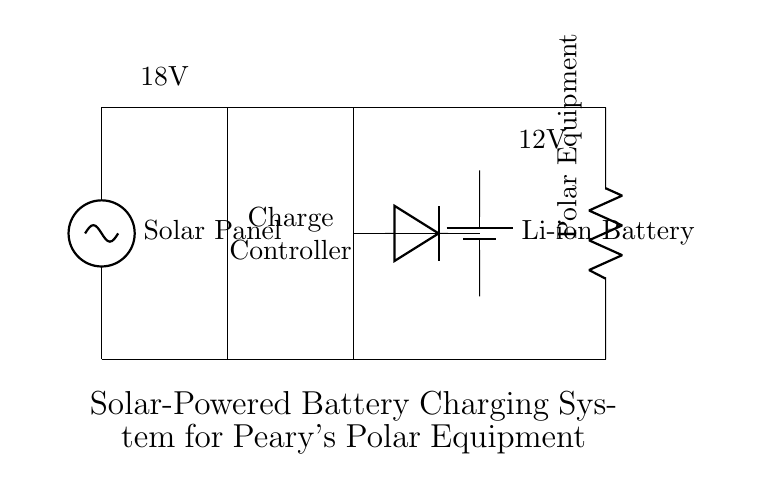What type of battery is used in this circuit? The circuit diagram indicates the use of a lithium-ion battery, as shown by the label next to the battery symbol.
Answer: Lithium-ion battery What is the voltage of the solar panel? The solar panel's voltage is specified in the diagram as 18 volts, which is indicated by the label above the solar panel symbol.
Answer: 18 volts Which component regulates the charging process? The charge controller is the component that regulates the charging process, as it is drawn as a rectangle labeled "Charge Controller" between the solar panel and battery.
Answer: Charge Controller What is the load connected to the battery? The load connected to the battery is represented as "Polar Equipment," indicated by the label next to the resistor symbol in the diagram.
Answer: Polar Equipment What is the purpose of the diode in this circuit? The diode allows current to flow in one direction only, preventing backflow from the battery to the solar panel, ensuring that the charging is effective and protects the components.
Answer: Prevents backflow How are the solar panel and load connected in the circuit? The solar panel connects directly to the charge controller, which then connects to the battery, and from the battery, the load is connected, creating a path for energy flow from one to the other.
Answer: Directly in series What is the voltage rating of the battery? The battery is rated at 12 volts, as indicated by the label next to the battery symbol in the diagram.
Answer: 12 volts 